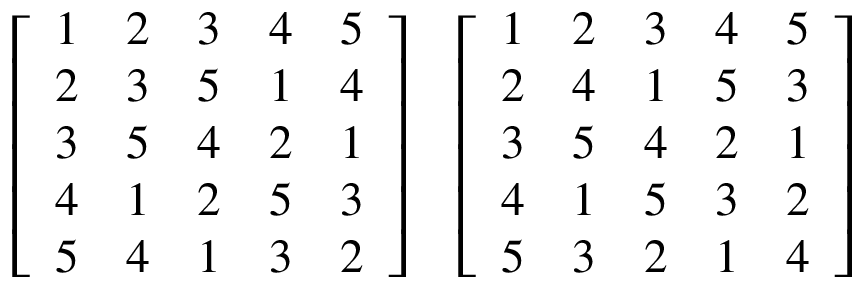<formula> <loc_0><loc_0><loc_500><loc_500>{ \left [ \begin{array} { l l l l l } { 1 } & { 2 } & { 3 } & { 4 } & { 5 } \\ { 2 } & { 3 } & { 5 } & { 1 } & { 4 } \\ { 3 } & { 5 } & { 4 } & { 2 } & { 1 } \\ { 4 } & { 1 } & { 2 } & { 5 } & { 3 } \\ { 5 } & { 4 } & { 1 } & { 3 } & { 2 } \end{array} \right ] } \quad \left [ \begin{array} { l l l l l } { 1 } & { 2 } & { 3 } & { 4 } & { 5 } \\ { 2 } & { 4 } & { 1 } & { 5 } & { 3 } \\ { 3 } & { 5 } & { 4 } & { 2 } & { 1 } \\ { 4 } & { 1 } & { 5 } & { 3 } & { 2 } \\ { 5 } & { 3 } & { 2 } & { 1 } & { 4 } \end{array} \right ]</formula> 